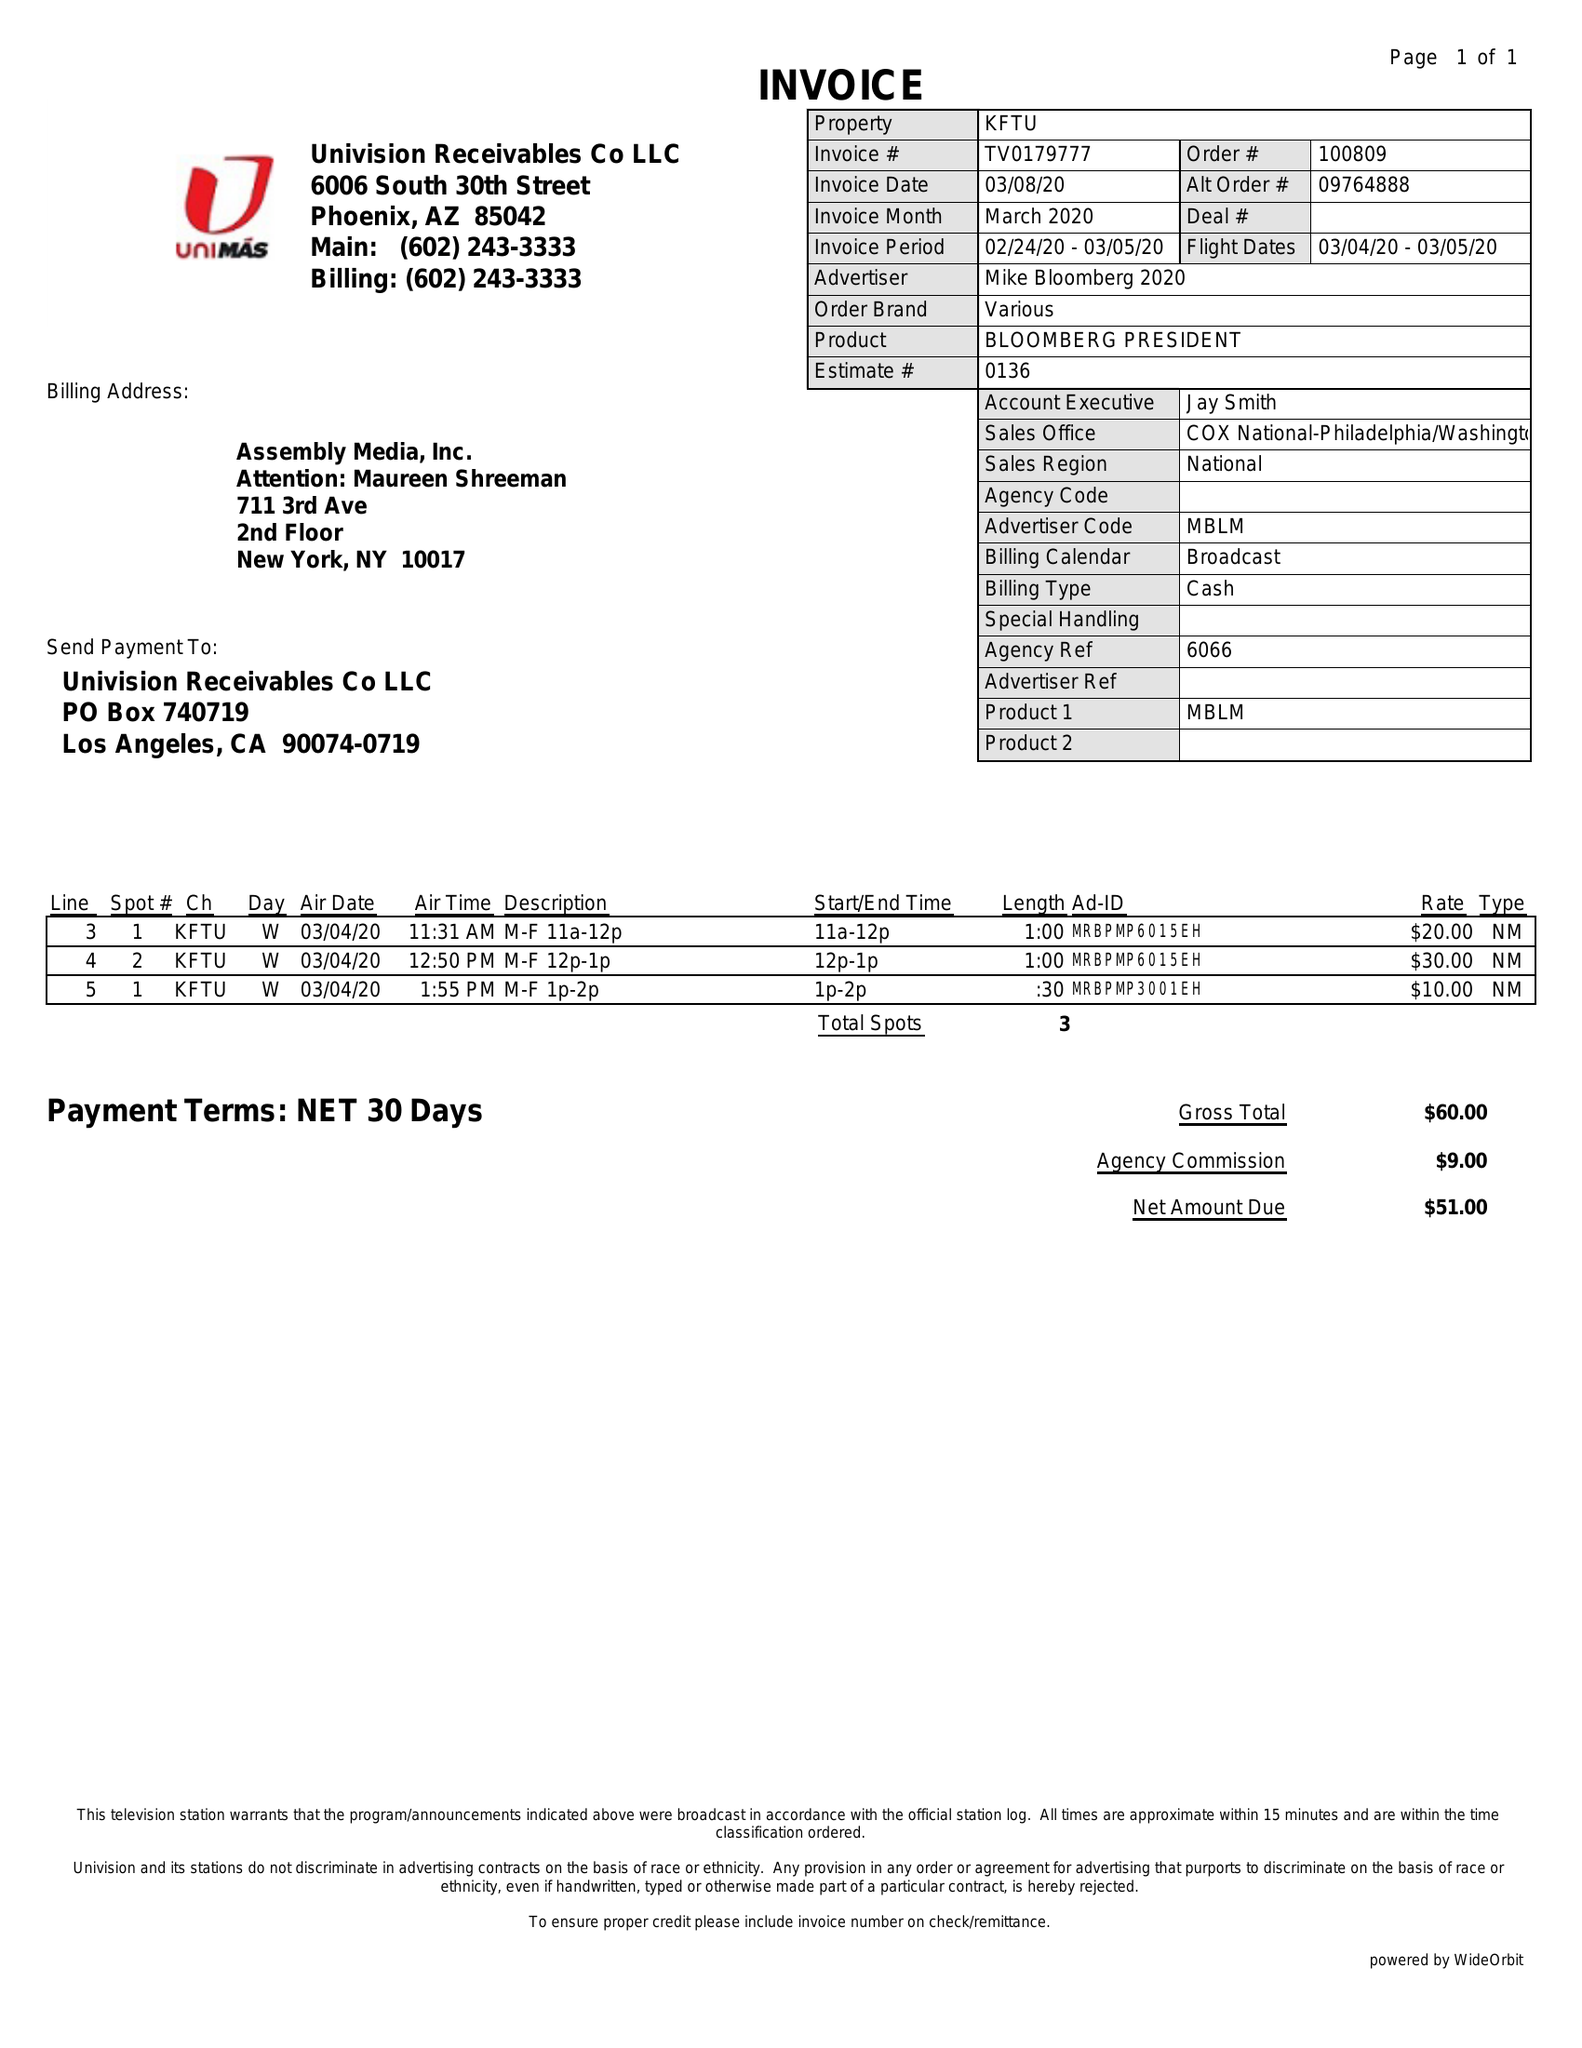What is the value for the flight_from?
Answer the question using a single word or phrase. 03/04/20 